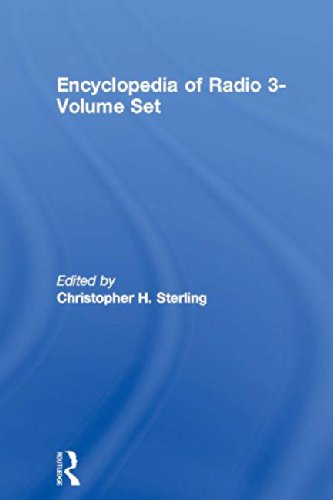Is this book related to Christian Books & Bibles? No, this book is not related to Christian Books & Bibles. It is a scholarly reference work that discusses radio, its technology and historical development. 